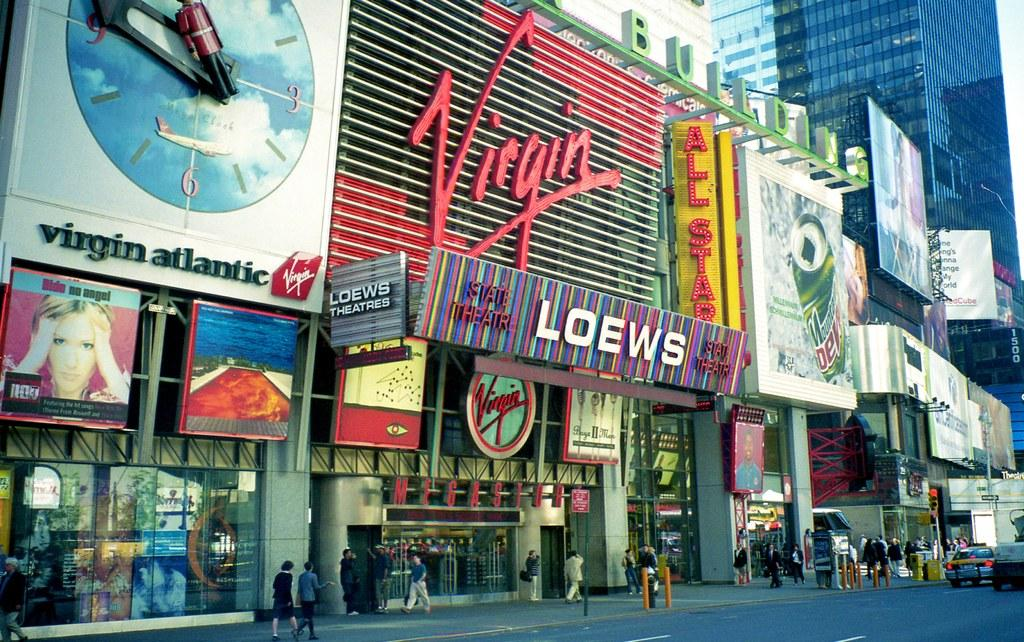What is happening with the group of people in the image? The people are walking on a footpath in the image. What else can be seen on the road in the image? There are cars on the road in the image. What additional elements are present in the image? Banners are present in the image. What can be seen in the distance in the image? There are buildings visible in the background of the image. Can you see any birds forming a circle in the image? There are no birds present in the image, and therefore no circle formation can be observed. 